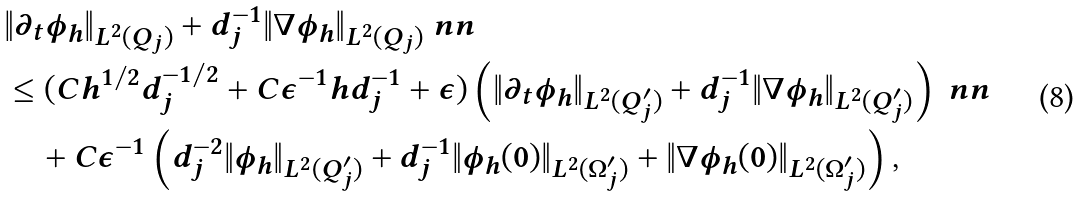<formula> <loc_0><loc_0><loc_500><loc_500>& \| \partial _ { t } \phi _ { h } \| _ { L ^ { 2 } ( Q _ { j } ) } + d _ { j } ^ { - 1 } \| \nabla \phi _ { h } \| _ { L ^ { 2 } ( Q _ { j } ) } \ n n \\ & \leq ( C h ^ { 1 / 2 } d _ { j } ^ { - 1 / 2 } + C \epsilon ^ { - 1 } h d _ { j } ^ { - 1 } + \epsilon ) \left ( \| \partial _ { t } \phi _ { h } \| _ { L ^ { 2 } ( Q _ { j } ^ { \prime } ) } + d _ { j } ^ { - 1 } \| \nabla \phi _ { h } \| _ { L ^ { 2 } ( Q _ { j } ^ { \prime } ) } \right ) \ n n \\ & \quad + C \epsilon ^ { - 1 } \left ( d _ { j } ^ { - 2 } \| \phi _ { h } \| _ { L ^ { 2 } ( Q _ { j } ^ { \prime } ) } + d _ { j } ^ { - 1 } \| \phi _ { h } ( 0 ) \| _ { L ^ { 2 } ( \Omega _ { j } ^ { \prime } ) } + \| \nabla \phi _ { h } ( 0 ) \| _ { L ^ { 2 } ( \Omega _ { j } ^ { \prime } ) } \right ) ,</formula> 